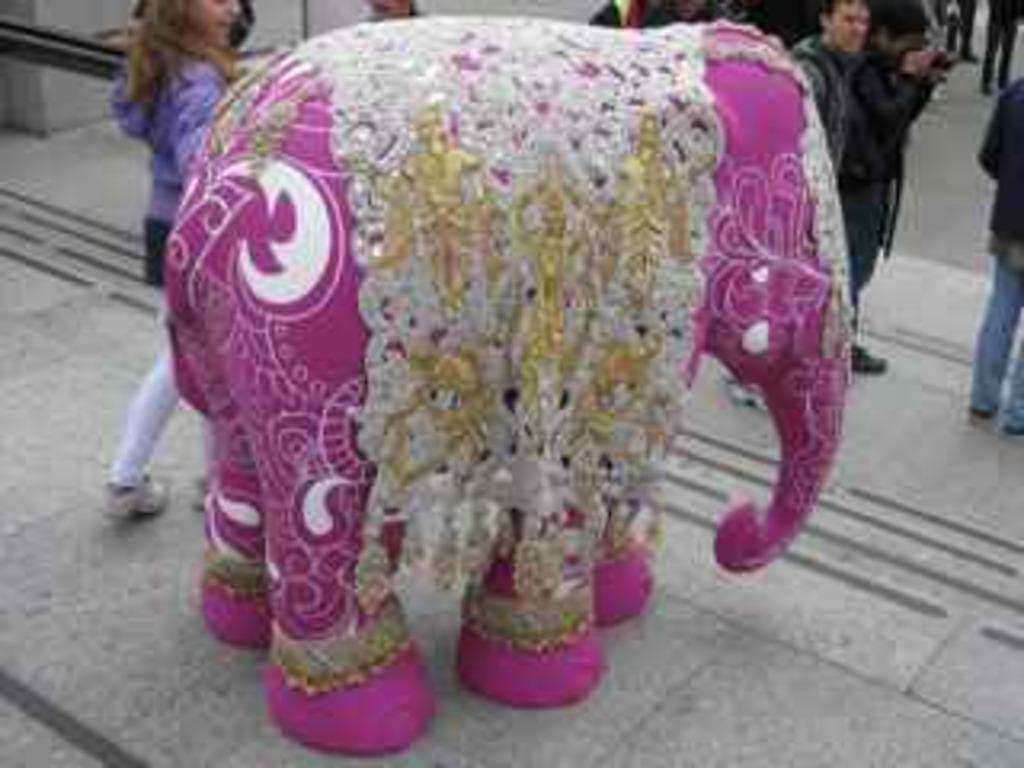What type of costume is in the picture? There is a costume of an elephant in the picture. What color is the costume? The costume is pink in color. Can you describe the background of the picture? There are people visible in the background of the picture. What type of print is visible on the costume? There is no print visible on the costume; it is a solid pink color. 